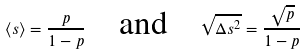Convert formula to latex. <formula><loc_0><loc_0><loc_500><loc_500>\langle s \rangle = \frac { p } { 1 - p } \quad \text {and} \quad \sqrt { \Delta s ^ { 2 } } = \frac { \sqrt { p } } { 1 - p }</formula> 